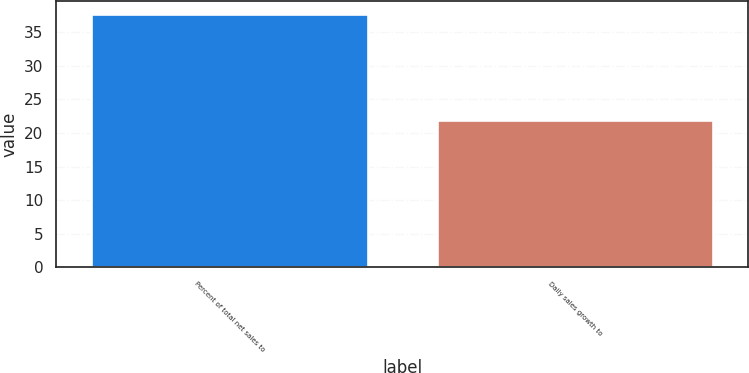<chart> <loc_0><loc_0><loc_500><loc_500><bar_chart><fcel>Percent of total net sales to<fcel>Daily sales growth to<nl><fcel>37.8<fcel>21.9<nl></chart> 